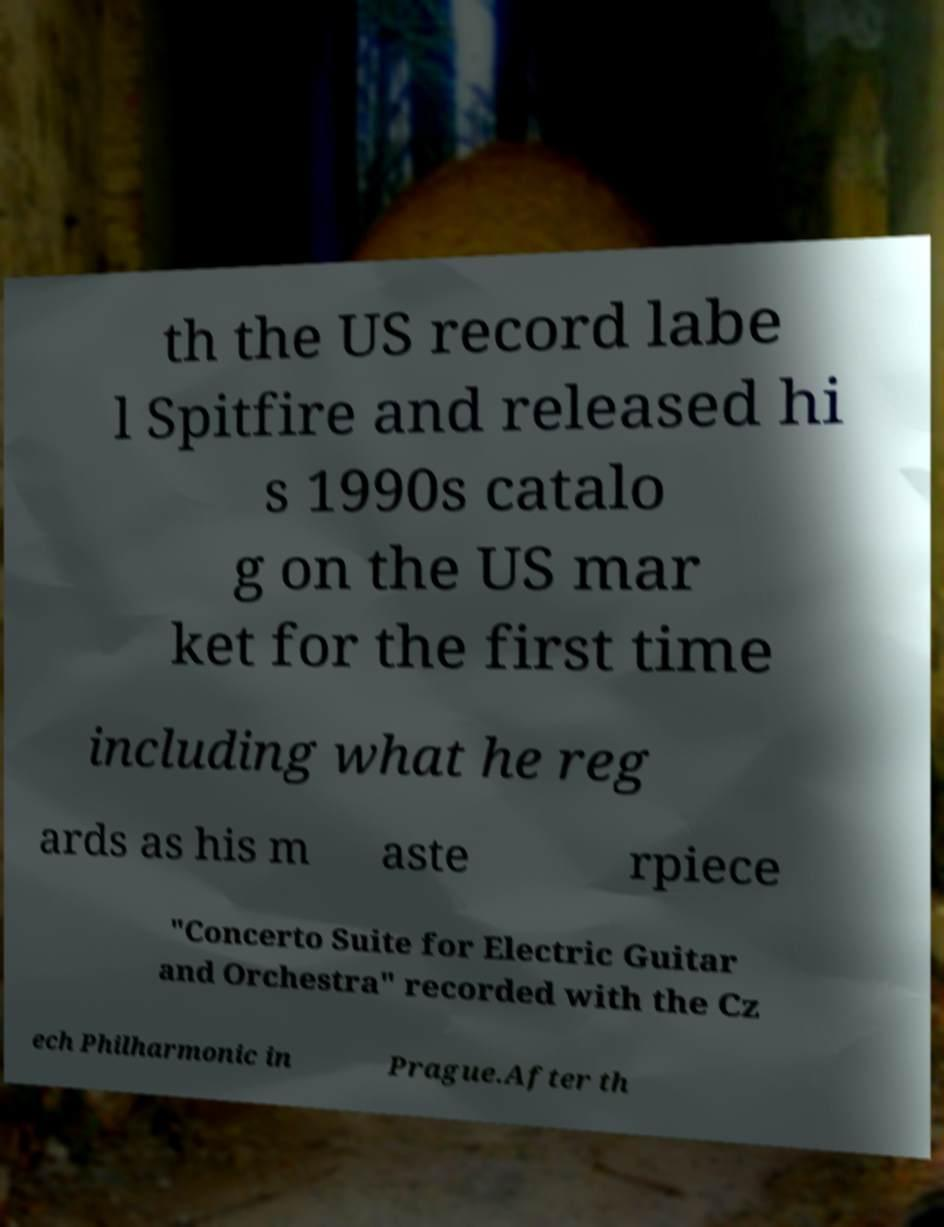Can you accurately transcribe the text from the provided image for me? th the US record labe l Spitfire and released hi s 1990s catalo g on the US mar ket for the first time including what he reg ards as his m aste rpiece "Concerto Suite for Electric Guitar and Orchestra" recorded with the Cz ech Philharmonic in Prague.After th 